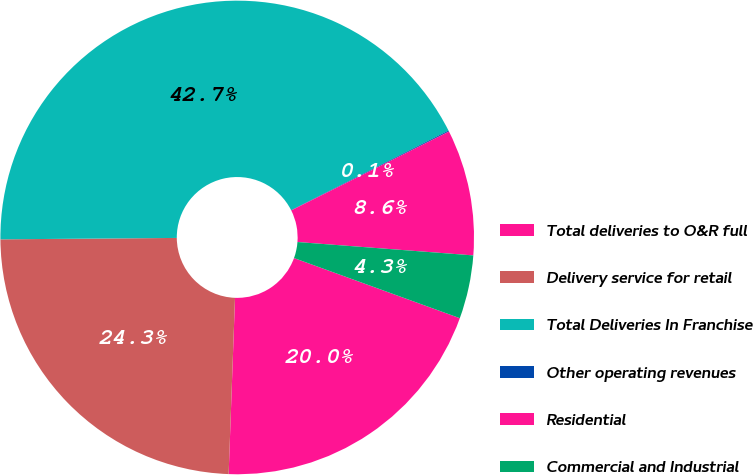Convert chart to OTSL. <chart><loc_0><loc_0><loc_500><loc_500><pie_chart><fcel>Total deliveries to O&R full<fcel>Delivery service for retail<fcel>Total Deliveries In Franchise<fcel>Other operating revenues<fcel>Residential<fcel>Commercial and Industrial<nl><fcel>20.04%<fcel>24.3%<fcel>42.68%<fcel>0.07%<fcel>8.59%<fcel>4.33%<nl></chart> 